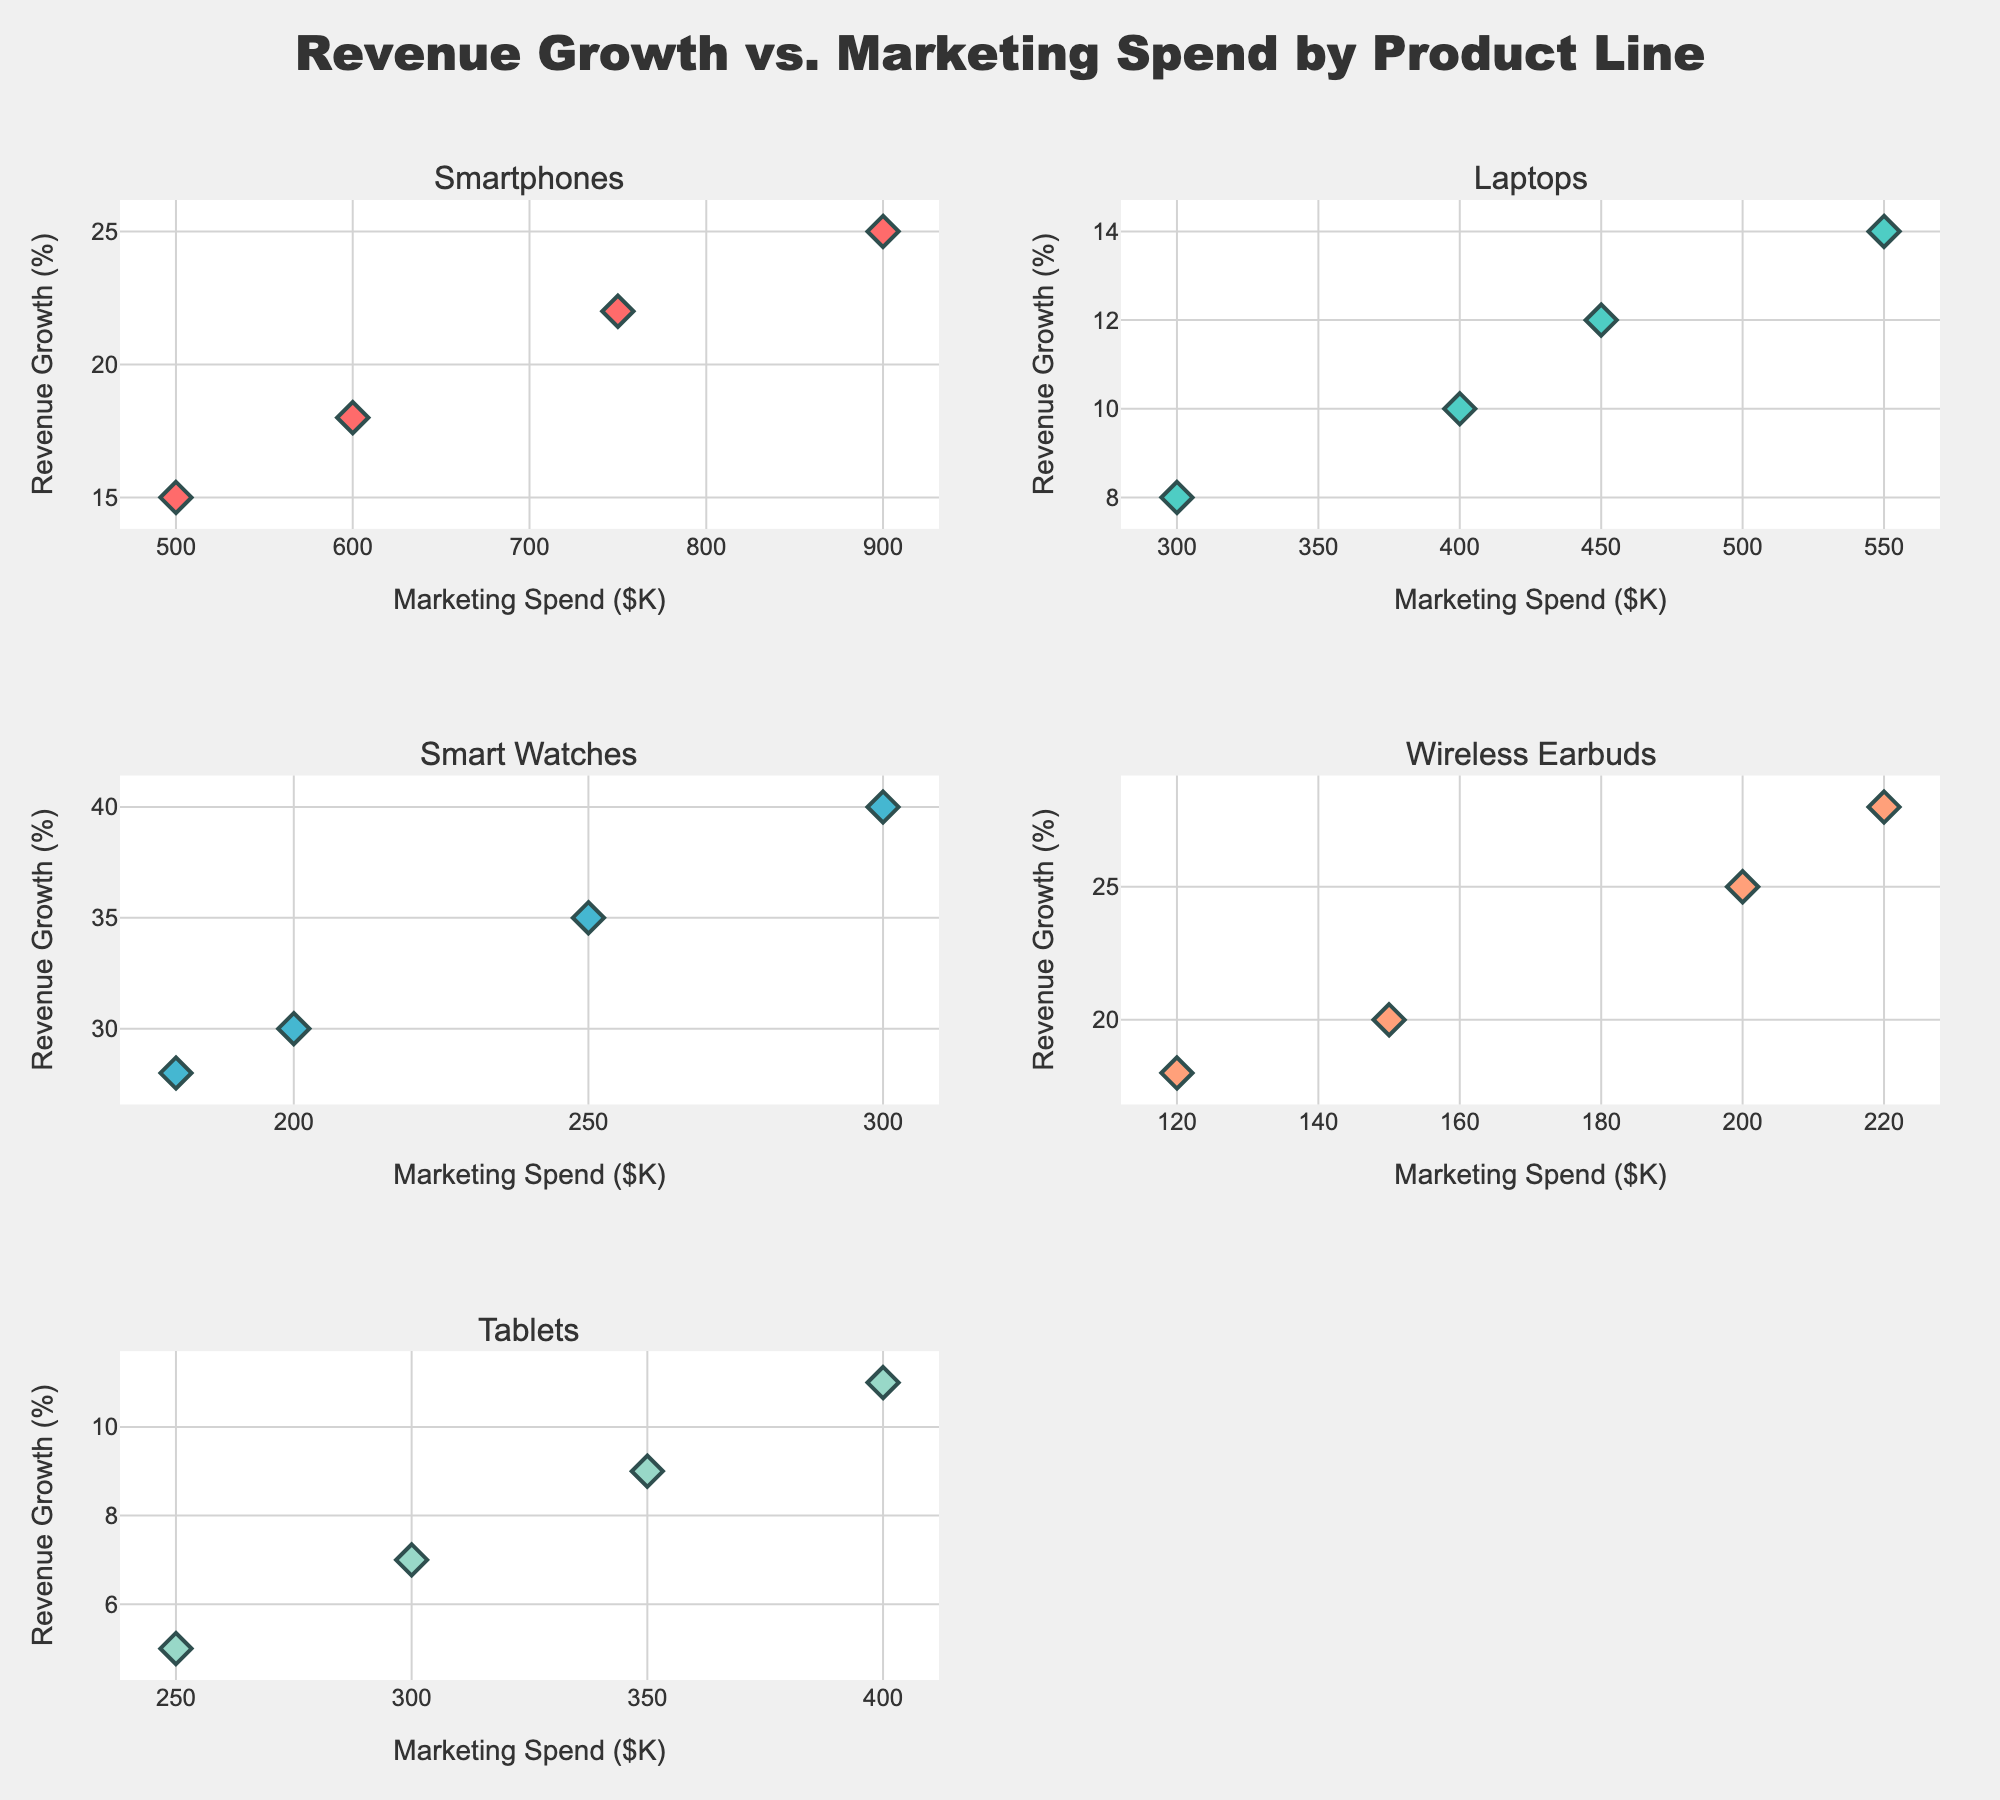what is the title of the figure? The title is prominently displayed at the top of the figure in a large font. It reads "Revenue Growth vs. Marketing Spend by Product Line".
Answer: Revenue Growth vs. Marketing Spend by Product Line how many product lines are displayed in the subplots? Each subplot represents a different product line, and there are five in total. By counting the number of subplot titles, you can confirm there are five product lines displayed.
Answer: five which product line has the highest data point for revenue growth and what is its value? By looking at the scatter plots, you can identify that the Smart Watches subplot has the highest revenue growth value. The highest data point reaches 40%.
Answer: Smart Watches, 40% what is the range of marketing spend for Tablets? Tablets’ subplot shows data points ranging in marketing spend values from 250K to 400K. One can see this by observing the x-axis values in that subplot.
Answer: 250K to 400K how does the marketing spend compare between Laptops and Wireless Earbuds for the highest revenue growth points? By observing the points with the highest revenue growth in both subplots, Laptops have a highest point of 14% with a marketing spend of 550K, while Wireless Earbuds have a highest point of 28% with a marketing spend of 220K. Hence, Wireless Earbuds achieve higher revenue growth with less marketing spend compared to Laptops.
Answer: Wireless Earbuds achieve higher growth with less spend find the average marketing spend for the Smart Watches product line. Sum the marketing spend values for Smart Watches, which are 200K, 250K, 180K, and 300K: (200 + 250 + 180 + 300) = 930. Divide by the total number of data points, which is 4, to get the average: 930/4 = 232.5K.
Answer: 232.5K which product line shows a wider range of revenue growth? By comparing the height span (vertical range) of points across all subplots, Smart Watches display the widest range of revenue growth spanning from 28% to 40%, indicating a range of 12%. Other product lines show narrower ranges.
Answer: Smart Watches does any product line display a consistent increase in revenue growth with marketing spend? Reviewing the scatter plots, Smart Watches tend to show a general upward trend where higher marketing spend correlates with higher revenue growth, indicating more consistency compared to other product lines.
Answer: Smart Watches how many data points are there in the Smartphones product line subplot? Each marker in the subplot represents a data point. Counting those gives the total number: there are 4 data points in the Smartphones subplot.
Answer: 4 